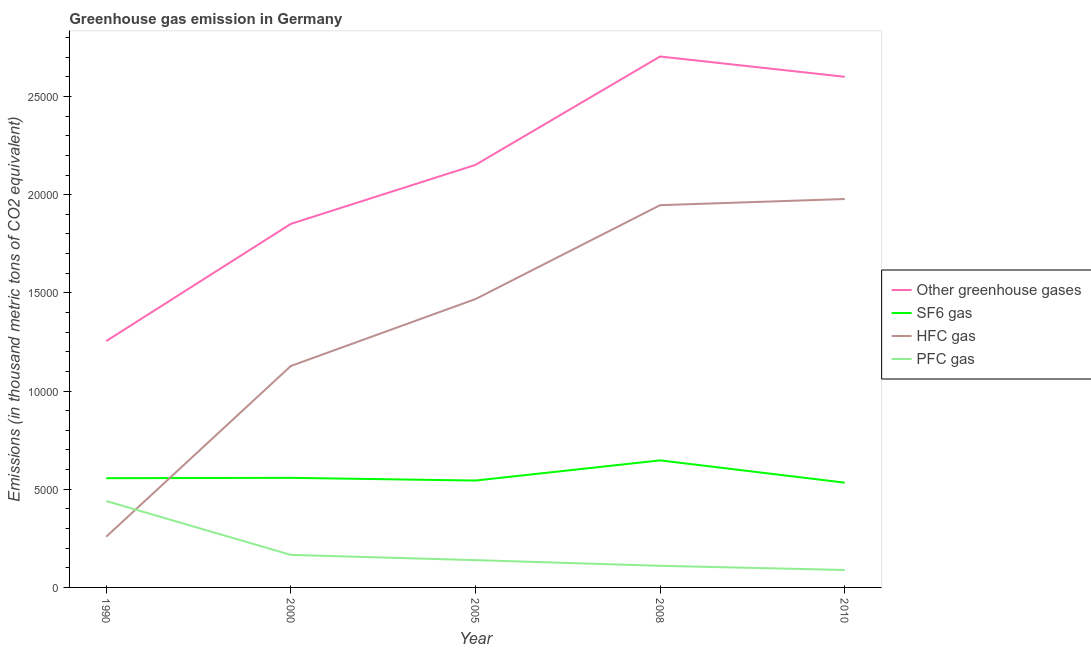Does the line corresponding to emission of hfc gas intersect with the line corresponding to emission of greenhouse gases?
Keep it short and to the point. No. What is the emission of hfc gas in 2005?
Your answer should be very brief. 1.47e+04. Across all years, what is the maximum emission of sf6 gas?
Keep it short and to the point. 6469.6. Across all years, what is the minimum emission of hfc gas?
Give a very brief answer. 2581.5. In which year was the emission of sf6 gas minimum?
Your response must be concise. 2010. What is the total emission of sf6 gas in the graph?
Provide a short and direct response. 2.84e+04. What is the difference between the emission of pfc gas in 2000 and that in 2005?
Your response must be concise. 266.2. What is the difference between the emission of sf6 gas in 2005 and the emission of hfc gas in 2008?
Provide a short and direct response. -1.40e+04. What is the average emission of greenhouse gases per year?
Offer a very short reply. 2.11e+04. In the year 2008, what is the difference between the emission of greenhouse gases and emission of hfc gas?
Your response must be concise. 7571. In how many years, is the emission of hfc gas greater than 17000 thousand metric tons?
Give a very brief answer. 2. What is the ratio of the emission of hfc gas in 2005 to that in 2008?
Provide a succinct answer. 0.75. Is the emission of sf6 gas in 1990 less than that in 2010?
Provide a short and direct response. No. What is the difference between the highest and the second highest emission of greenhouse gases?
Provide a succinct answer. 1033.8. What is the difference between the highest and the lowest emission of greenhouse gases?
Offer a very short reply. 1.45e+04. Is it the case that in every year, the sum of the emission of greenhouse gases and emission of pfc gas is greater than the sum of emission of hfc gas and emission of sf6 gas?
Offer a terse response. Yes. Is it the case that in every year, the sum of the emission of greenhouse gases and emission of sf6 gas is greater than the emission of hfc gas?
Offer a terse response. Yes. Is the emission of greenhouse gases strictly less than the emission of hfc gas over the years?
Provide a succinct answer. No. How many lines are there?
Provide a short and direct response. 4. How many years are there in the graph?
Offer a terse response. 5. What is the difference between two consecutive major ticks on the Y-axis?
Make the answer very short. 5000. Does the graph contain any zero values?
Give a very brief answer. No. Does the graph contain grids?
Your answer should be compact. No. Where does the legend appear in the graph?
Ensure brevity in your answer.  Center right. What is the title of the graph?
Ensure brevity in your answer.  Greenhouse gas emission in Germany. What is the label or title of the X-axis?
Ensure brevity in your answer.  Year. What is the label or title of the Y-axis?
Provide a succinct answer. Emissions (in thousand metric tons of CO2 equivalent). What is the Emissions (in thousand metric tons of CO2 equivalent) in Other greenhouse gases in 1990?
Provide a succinct answer. 1.25e+04. What is the Emissions (in thousand metric tons of CO2 equivalent) in SF6 gas in 1990?
Make the answer very short. 5562.9. What is the Emissions (in thousand metric tons of CO2 equivalent) in HFC gas in 1990?
Provide a short and direct response. 2581.5. What is the Emissions (in thousand metric tons of CO2 equivalent) of PFC gas in 1990?
Offer a terse response. 4401.3. What is the Emissions (in thousand metric tons of CO2 equivalent) in Other greenhouse gases in 2000?
Give a very brief answer. 1.85e+04. What is the Emissions (in thousand metric tons of CO2 equivalent) of SF6 gas in 2000?
Ensure brevity in your answer.  5580.4. What is the Emissions (in thousand metric tons of CO2 equivalent) in HFC gas in 2000?
Your answer should be compact. 1.13e+04. What is the Emissions (in thousand metric tons of CO2 equivalent) of PFC gas in 2000?
Your answer should be compact. 1655.9. What is the Emissions (in thousand metric tons of CO2 equivalent) in Other greenhouse gases in 2005?
Your answer should be compact. 2.15e+04. What is the Emissions (in thousand metric tons of CO2 equivalent) of SF6 gas in 2005?
Your response must be concise. 5443.2. What is the Emissions (in thousand metric tons of CO2 equivalent) in HFC gas in 2005?
Offer a terse response. 1.47e+04. What is the Emissions (in thousand metric tons of CO2 equivalent) of PFC gas in 2005?
Offer a terse response. 1389.7. What is the Emissions (in thousand metric tons of CO2 equivalent) in Other greenhouse gases in 2008?
Offer a terse response. 2.70e+04. What is the Emissions (in thousand metric tons of CO2 equivalent) of SF6 gas in 2008?
Ensure brevity in your answer.  6469.6. What is the Emissions (in thousand metric tons of CO2 equivalent) of HFC gas in 2008?
Provide a short and direct response. 1.95e+04. What is the Emissions (in thousand metric tons of CO2 equivalent) in PFC gas in 2008?
Keep it short and to the point. 1101.4. What is the Emissions (in thousand metric tons of CO2 equivalent) of Other greenhouse gases in 2010?
Make the answer very short. 2.60e+04. What is the Emissions (in thousand metric tons of CO2 equivalent) of SF6 gas in 2010?
Provide a succinct answer. 5336. What is the Emissions (in thousand metric tons of CO2 equivalent) in HFC gas in 2010?
Make the answer very short. 1.98e+04. What is the Emissions (in thousand metric tons of CO2 equivalent) in PFC gas in 2010?
Your response must be concise. 888. Across all years, what is the maximum Emissions (in thousand metric tons of CO2 equivalent) of Other greenhouse gases?
Make the answer very short. 2.70e+04. Across all years, what is the maximum Emissions (in thousand metric tons of CO2 equivalent) in SF6 gas?
Give a very brief answer. 6469.6. Across all years, what is the maximum Emissions (in thousand metric tons of CO2 equivalent) in HFC gas?
Offer a very short reply. 1.98e+04. Across all years, what is the maximum Emissions (in thousand metric tons of CO2 equivalent) in PFC gas?
Provide a succinct answer. 4401.3. Across all years, what is the minimum Emissions (in thousand metric tons of CO2 equivalent) of Other greenhouse gases?
Provide a short and direct response. 1.25e+04. Across all years, what is the minimum Emissions (in thousand metric tons of CO2 equivalent) of SF6 gas?
Your response must be concise. 5336. Across all years, what is the minimum Emissions (in thousand metric tons of CO2 equivalent) in HFC gas?
Your response must be concise. 2581.5. Across all years, what is the minimum Emissions (in thousand metric tons of CO2 equivalent) of PFC gas?
Provide a short and direct response. 888. What is the total Emissions (in thousand metric tons of CO2 equivalent) in Other greenhouse gases in the graph?
Offer a very short reply. 1.06e+05. What is the total Emissions (in thousand metric tons of CO2 equivalent) in SF6 gas in the graph?
Your answer should be very brief. 2.84e+04. What is the total Emissions (in thousand metric tons of CO2 equivalent) of HFC gas in the graph?
Give a very brief answer. 6.78e+04. What is the total Emissions (in thousand metric tons of CO2 equivalent) of PFC gas in the graph?
Give a very brief answer. 9436.3. What is the difference between the Emissions (in thousand metric tons of CO2 equivalent) in Other greenhouse gases in 1990 and that in 2000?
Offer a terse response. -5968.2. What is the difference between the Emissions (in thousand metric tons of CO2 equivalent) in SF6 gas in 1990 and that in 2000?
Give a very brief answer. -17.5. What is the difference between the Emissions (in thousand metric tons of CO2 equivalent) in HFC gas in 1990 and that in 2000?
Keep it short and to the point. -8696.1. What is the difference between the Emissions (in thousand metric tons of CO2 equivalent) in PFC gas in 1990 and that in 2000?
Provide a succinct answer. 2745.4. What is the difference between the Emissions (in thousand metric tons of CO2 equivalent) of Other greenhouse gases in 1990 and that in 2005?
Your answer should be very brief. -8971.8. What is the difference between the Emissions (in thousand metric tons of CO2 equivalent) in SF6 gas in 1990 and that in 2005?
Your answer should be compact. 119.7. What is the difference between the Emissions (in thousand metric tons of CO2 equivalent) in HFC gas in 1990 and that in 2005?
Your response must be concise. -1.21e+04. What is the difference between the Emissions (in thousand metric tons of CO2 equivalent) in PFC gas in 1990 and that in 2005?
Your answer should be compact. 3011.6. What is the difference between the Emissions (in thousand metric tons of CO2 equivalent) in Other greenhouse gases in 1990 and that in 2008?
Ensure brevity in your answer.  -1.45e+04. What is the difference between the Emissions (in thousand metric tons of CO2 equivalent) of SF6 gas in 1990 and that in 2008?
Your answer should be compact. -906.7. What is the difference between the Emissions (in thousand metric tons of CO2 equivalent) in HFC gas in 1990 and that in 2008?
Provide a succinct answer. -1.69e+04. What is the difference between the Emissions (in thousand metric tons of CO2 equivalent) in PFC gas in 1990 and that in 2008?
Provide a succinct answer. 3299.9. What is the difference between the Emissions (in thousand metric tons of CO2 equivalent) in Other greenhouse gases in 1990 and that in 2010?
Ensure brevity in your answer.  -1.35e+04. What is the difference between the Emissions (in thousand metric tons of CO2 equivalent) in SF6 gas in 1990 and that in 2010?
Make the answer very short. 226.9. What is the difference between the Emissions (in thousand metric tons of CO2 equivalent) in HFC gas in 1990 and that in 2010?
Your answer should be very brief. -1.72e+04. What is the difference between the Emissions (in thousand metric tons of CO2 equivalent) of PFC gas in 1990 and that in 2010?
Provide a short and direct response. 3513.3. What is the difference between the Emissions (in thousand metric tons of CO2 equivalent) in Other greenhouse gases in 2000 and that in 2005?
Provide a short and direct response. -3003.6. What is the difference between the Emissions (in thousand metric tons of CO2 equivalent) in SF6 gas in 2000 and that in 2005?
Offer a very short reply. 137.2. What is the difference between the Emissions (in thousand metric tons of CO2 equivalent) in HFC gas in 2000 and that in 2005?
Keep it short and to the point. -3407. What is the difference between the Emissions (in thousand metric tons of CO2 equivalent) of PFC gas in 2000 and that in 2005?
Offer a very short reply. 266.2. What is the difference between the Emissions (in thousand metric tons of CO2 equivalent) in Other greenhouse gases in 2000 and that in 2008?
Keep it short and to the point. -8523.9. What is the difference between the Emissions (in thousand metric tons of CO2 equivalent) in SF6 gas in 2000 and that in 2008?
Provide a succinct answer. -889.2. What is the difference between the Emissions (in thousand metric tons of CO2 equivalent) in HFC gas in 2000 and that in 2008?
Keep it short and to the point. -8189.2. What is the difference between the Emissions (in thousand metric tons of CO2 equivalent) in PFC gas in 2000 and that in 2008?
Make the answer very short. 554.5. What is the difference between the Emissions (in thousand metric tons of CO2 equivalent) in Other greenhouse gases in 2000 and that in 2010?
Keep it short and to the point. -7490.1. What is the difference between the Emissions (in thousand metric tons of CO2 equivalent) in SF6 gas in 2000 and that in 2010?
Your response must be concise. 244.4. What is the difference between the Emissions (in thousand metric tons of CO2 equivalent) in HFC gas in 2000 and that in 2010?
Provide a short and direct response. -8502.4. What is the difference between the Emissions (in thousand metric tons of CO2 equivalent) of PFC gas in 2000 and that in 2010?
Provide a short and direct response. 767.9. What is the difference between the Emissions (in thousand metric tons of CO2 equivalent) in Other greenhouse gases in 2005 and that in 2008?
Ensure brevity in your answer.  -5520.3. What is the difference between the Emissions (in thousand metric tons of CO2 equivalent) in SF6 gas in 2005 and that in 2008?
Your answer should be compact. -1026.4. What is the difference between the Emissions (in thousand metric tons of CO2 equivalent) of HFC gas in 2005 and that in 2008?
Offer a very short reply. -4782.2. What is the difference between the Emissions (in thousand metric tons of CO2 equivalent) in PFC gas in 2005 and that in 2008?
Provide a short and direct response. 288.3. What is the difference between the Emissions (in thousand metric tons of CO2 equivalent) in Other greenhouse gases in 2005 and that in 2010?
Ensure brevity in your answer.  -4486.5. What is the difference between the Emissions (in thousand metric tons of CO2 equivalent) of SF6 gas in 2005 and that in 2010?
Give a very brief answer. 107.2. What is the difference between the Emissions (in thousand metric tons of CO2 equivalent) of HFC gas in 2005 and that in 2010?
Keep it short and to the point. -5095.4. What is the difference between the Emissions (in thousand metric tons of CO2 equivalent) in PFC gas in 2005 and that in 2010?
Ensure brevity in your answer.  501.7. What is the difference between the Emissions (in thousand metric tons of CO2 equivalent) in Other greenhouse gases in 2008 and that in 2010?
Offer a terse response. 1033.8. What is the difference between the Emissions (in thousand metric tons of CO2 equivalent) in SF6 gas in 2008 and that in 2010?
Offer a very short reply. 1133.6. What is the difference between the Emissions (in thousand metric tons of CO2 equivalent) in HFC gas in 2008 and that in 2010?
Provide a short and direct response. -313.2. What is the difference between the Emissions (in thousand metric tons of CO2 equivalent) in PFC gas in 2008 and that in 2010?
Provide a succinct answer. 213.4. What is the difference between the Emissions (in thousand metric tons of CO2 equivalent) in Other greenhouse gases in 1990 and the Emissions (in thousand metric tons of CO2 equivalent) in SF6 gas in 2000?
Your answer should be compact. 6965.3. What is the difference between the Emissions (in thousand metric tons of CO2 equivalent) in Other greenhouse gases in 1990 and the Emissions (in thousand metric tons of CO2 equivalent) in HFC gas in 2000?
Offer a very short reply. 1268.1. What is the difference between the Emissions (in thousand metric tons of CO2 equivalent) in Other greenhouse gases in 1990 and the Emissions (in thousand metric tons of CO2 equivalent) in PFC gas in 2000?
Provide a short and direct response. 1.09e+04. What is the difference between the Emissions (in thousand metric tons of CO2 equivalent) in SF6 gas in 1990 and the Emissions (in thousand metric tons of CO2 equivalent) in HFC gas in 2000?
Keep it short and to the point. -5714.7. What is the difference between the Emissions (in thousand metric tons of CO2 equivalent) in SF6 gas in 1990 and the Emissions (in thousand metric tons of CO2 equivalent) in PFC gas in 2000?
Offer a very short reply. 3907. What is the difference between the Emissions (in thousand metric tons of CO2 equivalent) in HFC gas in 1990 and the Emissions (in thousand metric tons of CO2 equivalent) in PFC gas in 2000?
Offer a terse response. 925.6. What is the difference between the Emissions (in thousand metric tons of CO2 equivalent) in Other greenhouse gases in 1990 and the Emissions (in thousand metric tons of CO2 equivalent) in SF6 gas in 2005?
Offer a very short reply. 7102.5. What is the difference between the Emissions (in thousand metric tons of CO2 equivalent) of Other greenhouse gases in 1990 and the Emissions (in thousand metric tons of CO2 equivalent) of HFC gas in 2005?
Ensure brevity in your answer.  -2138.9. What is the difference between the Emissions (in thousand metric tons of CO2 equivalent) of Other greenhouse gases in 1990 and the Emissions (in thousand metric tons of CO2 equivalent) of PFC gas in 2005?
Offer a terse response. 1.12e+04. What is the difference between the Emissions (in thousand metric tons of CO2 equivalent) in SF6 gas in 1990 and the Emissions (in thousand metric tons of CO2 equivalent) in HFC gas in 2005?
Provide a short and direct response. -9121.7. What is the difference between the Emissions (in thousand metric tons of CO2 equivalent) of SF6 gas in 1990 and the Emissions (in thousand metric tons of CO2 equivalent) of PFC gas in 2005?
Make the answer very short. 4173.2. What is the difference between the Emissions (in thousand metric tons of CO2 equivalent) in HFC gas in 1990 and the Emissions (in thousand metric tons of CO2 equivalent) in PFC gas in 2005?
Give a very brief answer. 1191.8. What is the difference between the Emissions (in thousand metric tons of CO2 equivalent) in Other greenhouse gases in 1990 and the Emissions (in thousand metric tons of CO2 equivalent) in SF6 gas in 2008?
Your response must be concise. 6076.1. What is the difference between the Emissions (in thousand metric tons of CO2 equivalent) of Other greenhouse gases in 1990 and the Emissions (in thousand metric tons of CO2 equivalent) of HFC gas in 2008?
Your answer should be very brief. -6921.1. What is the difference between the Emissions (in thousand metric tons of CO2 equivalent) in Other greenhouse gases in 1990 and the Emissions (in thousand metric tons of CO2 equivalent) in PFC gas in 2008?
Offer a very short reply. 1.14e+04. What is the difference between the Emissions (in thousand metric tons of CO2 equivalent) of SF6 gas in 1990 and the Emissions (in thousand metric tons of CO2 equivalent) of HFC gas in 2008?
Provide a short and direct response. -1.39e+04. What is the difference between the Emissions (in thousand metric tons of CO2 equivalent) of SF6 gas in 1990 and the Emissions (in thousand metric tons of CO2 equivalent) of PFC gas in 2008?
Your response must be concise. 4461.5. What is the difference between the Emissions (in thousand metric tons of CO2 equivalent) of HFC gas in 1990 and the Emissions (in thousand metric tons of CO2 equivalent) of PFC gas in 2008?
Ensure brevity in your answer.  1480.1. What is the difference between the Emissions (in thousand metric tons of CO2 equivalent) of Other greenhouse gases in 1990 and the Emissions (in thousand metric tons of CO2 equivalent) of SF6 gas in 2010?
Make the answer very short. 7209.7. What is the difference between the Emissions (in thousand metric tons of CO2 equivalent) in Other greenhouse gases in 1990 and the Emissions (in thousand metric tons of CO2 equivalent) in HFC gas in 2010?
Keep it short and to the point. -7234.3. What is the difference between the Emissions (in thousand metric tons of CO2 equivalent) in Other greenhouse gases in 1990 and the Emissions (in thousand metric tons of CO2 equivalent) in PFC gas in 2010?
Your answer should be compact. 1.17e+04. What is the difference between the Emissions (in thousand metric tons of CO2 equivalent) of SF6 gas in 1990 and the Emissions (in thousand metric tons of CO2 equivalent) of HFC gas in 2010?
Make the answer very short. -1.42e+04. What is the difference between the Emissions (in thousand metric tons of CO2 equivalent) in SF6 gas in 1990 and the Emissions (in thousand metric tons of CO2 equivalent) in PFC gas in 2010?
Keep it short and to the point. 4674.9. What is the difference between the Emissions (in thousand metric tons of CO2 equivalent) of HFC gas in 1990 and the Emissions (in thousand metric tons of CO2 equivalent) of PFC gas in 2010?
Your answer should be compact. 1693.5. What is the difference between the Emissions (in thousand metric tons of CO2 equivalent) of Other greenhouse gases in 2000 and the Emissions (in thousand metric tons of CO2 equivalent) of SF6 gas in 2005?
Provide a succinct answer. 1.31e+04. What is the difference between the Emissions (in thousand metric tons of CO2 equivalent) in Other greenhouse gases in 2000 and the Emissions (in thousand metric tons of CO2 equivalent) in HFC gas in 2005?
Make the answer very short. 3829.3. What is the difference between the Emissions (in thousand metric tons of CO2 equivalent) of Other greenhouse gases in 2000 and the Emissions (in thousand metric tons of CO2 equivalent) of PFC gas in 2005?
Your response must be concise. 1.71e+04. What is the difference between the Emissions (in thousand metric tons of CO2 equivalent) of SF6 gas in 2000 and the Emissions (in thousand metric tons of CO2 equivalent) of HFC gas in 2005?
Give a very brief answer. -9104.2. What is the difference between the Emissions (in thousand metric tons of CO2 equivalent) in SF6 gas in 2000 and the Emissions (in thousand metric tons of CO2 equivalent) in PFC gas in 2005?
Your answer should be compact. 4190.7. What is the difference between the Emissions (in thousand metric tons of CO2 equivalent) in HFC gas in 2000 and the Emissions (in thousand metric tons of CO2 equivalent) in PFC gas in 2005?
Your response must be concise. 9887.9. What is the difference between the Emissions (in thousand metric tons of CO2 equivalent) of Other greenhouse gases in 2000 and the Emissions (in thousand metric tons of CO2 equivalent) of SF6 gas in 2008?
Your response must be concise. 1.20e+04. What is the difference between the Emissions (in thousand metric tons of CO2 equivalent) of Other greenhouse gases in 2000 and the Emissions (in thousand metric tons of CO2 equivalent) of HFC gas in 2008?
Provide a short and direct response. -952.9. What is the difference between the Emissions (in thousand metric tons of CO2 equivalent) in Other greenhouse gases in 2000 and the Emissions (in thousand metric tons of CO2 equivalent) in PFC gas in 2008?
Offer a terse response. 1.74e+04. What is the difference between the Emissions (in thousand metric tons of CO2 equivalent) of SF6 gas in 2000 and the Emissions (in thousand metric tons of CO2 equivalent) of HFC gas in 2008?
Offer a terse response. -1.39e+04. What is the difference between the Emissions (in thousand metric tons of CO2 equivalent) in SF6 gas in 2000 and the Emissions (in thousand metric tons of CO2 equivalent) in PFC gas in 2008?
Provide a short and direct response. 4479. What is the difference between the Emissions (in thousand metric tons of CO2 equivalent) in HFC gas in 2000 and the Emissions (in thousand metric tons of CO2 equivalent) in PFC gas in 2008?
Provide a succinct answer. 1.02e+04. What is the difference between the Emissions (in thousand metric tons of CO2 equivalent) in Other greenhouse gases in 2000 and the Emissions (in thousand metric tons of CO2 equivalent) in SF6 gas in 2010?
Ensure brevity in your answer.  1.32e+04. What is the difference between the Emissions (in thousand metric tons of CO2 equivalent) of Other greenhouse gases in 2000 and the Emissions (in thousand metric tons of CO2 equivalent) of HFC gas in 2010?
Give a very brief answer. -1266.1. What is the difference between the Emissions (in thousand metric tons of CO2 equivalent) of Other greenhouse gases in 2000 and the Emissions (in thousand metric tons of CO2 equivalent) of PFC gas in 2010?
Ensure brevity in your answer.  1.76e+04. What is the difference between the Emissions (in thousand metric tons of CO2 equivalent) of SF6 gas in 2000 and the Emissions (in thousand metric tons of CO2 equivalent) of HFC gas in 2010?
Your answer should be very brief. -1.42e+04. What is the difference between the Emissions (in thousand metric tons of CO2 equivalent) in SF6 gas in 2000 and the Emissions (in thousand metric tons of CO2 equivalent) in PFC gas in 2010?
Offer a very short reply. 4692.4. What is the difference between the Emissions (in thousand metric tons of CO2 equivalent) of HFC gas in 2000 and the Emissions (in thousand metric tons of CO2 equivalent) of PFC gas in 2010?
Your answer should be very brief. 1.04e+04. What is the difference between the Emissions (in thousand metric tons of CO2 equivalent) in Other greenhouse gases in 2005 and the Emissions (in thousand metric tons of CO2 equivalent) in SF6 gas in 2008?
Give a very brief answer. 1.50e+04. What is the difference between the Emissions (in thousand metric tons of CO2 equivalent) of Other greenhouse gases in 2005 and the Emissions (in thousand metric tons of CO2 equivalent) of HFC gas in 2008?
Provide a succinct answer. 2050.7. What is the difference between the Emissions (in thousand metric tons of CO2 equivalent) in Other greenhouse gases in 2005 and the Emissions (in thousand metric tons of CO2 equivalent) in PFC gas in 2008?
Give a very brief answer. 2.04e+04. What is the difference between the Emissions (in thousand metric tons of CO2 equivalent) of SF6 gas in 2005 and the Emissions (in thousand metric tons of CO2 equivalent) of HFC gas in 2008?
Ensure brevity in your answer.  -1.40e+04. What is the difference between the Emissions (in thousand metric tons of CO2 equivalent) of SF6 gas in 2005 and the Emissions (in thousand metric tons of CO2 equivalent) of PFC gas in 2008?
Provide a succinct answer. 4341.8. What is the difference between the Emissions (in thousand metric tons of CO2 equivalent) in HFC gas in 2005 and the Emissions (in thousand metric tons of CO2 equivalent) in PFC gas in 2008?
Your answer should be compact. 1.36e+04. What is the difference between the Emissions (in thousand metric tons of CO2 equivalent) in Other greenhouse gases in 2005 and the Emissions (in thousand metric tons of CO2 equivalent) in SF6 gas in 2010?
Make the answer very short. 1.62e+04. What is the difference between the Emissions (in thousand metric tons of CO2 equivalent) of Other greenhouse gases in 2005 and the Emissions (in thousand metric tons of CO2 equivalent) of HFC gas in 2010?
Offer a terse response. 1737.5. What is the difference between the Emissions (in thousand metric tons of CO2 equivalent) in Other greenhouse gases in 2005 and the Emissions (in thousand metric tons of CO2 equivalent) in PFC gas in 2010?
Your answer should be very brief. 2.06e+04. What is the difference between the Emissions (in thousand metric tons of CO2 equivalent) in SF6 gas in 2005 and the Emissions (in thousand metric tons of CO2 equivalent) in HFC gas in 2010?
Offer a terse response. -1.43e+04. What is the difference between the Emissions (in thousand metric tons of CO2 equivalent) of SF6 gas in 2005 and the Emissions (in thousand metric tons of CO2 equivalent) of PFC gas in 2010?
Keep it short and to the point. 4555.2. What is the difference between the Emissions (in thousand metric tons of CO2 equivalent) of HFC gas in 2005 and the Emissions (in thousand metric tons of CO2 equivalent) of PFC gas in 2010?
Your answer should be compact. 1.38e+04. What is the difference between the Emissions (in thousand metric tons of CO2 equivalent) of Other greenhouse gases in 2008 and the Emissions (in thousand metric tons of CO2 equivalent) of SF6 gas in 2010?
Your answer should be very brief. 2.17e+04. What is the difference between the Emissions (in thousand metric tons of CO2 equivalent) of Other greenhouse gases in 2008 and the Emissions (in thousand metric tons of CO2 equivalent) of HFC gas in 2010?
Your answer should be compact. 7257.8. What is the difference between the Emissions (in thousand metric tons of CO2 equivalent) in Other greenhouse gases in 2008 and the Emissions (in thousand metric tons of CO2 equivalent) in PFC gas in 2010?
Offer a terse response. 2.61e+04. What is the difference between the Emissions (in thousand metric tons of CO2 equivalent) in SF6 gas in 2008 and the Emissions (in thousand metric tons of CO2 equivalent) in HFC gas in 2010?
Ensure brevity in your answer.  -1.33e+04. What is the difference between the Emissions (in thousand metric tons of CO2 equivalent) in SF6 gas in 2008 and the Emissions (in thousand metric tons of CO2 equivalent) in PFC gas in 2010?
Offer a very short reply. 5581.6. What is the difference between the Emissions (in thousand metric tons of CO2 equivalent) in HFC gas in 2008 and the Emissions (in thousand metric tons of CO2 equivalent) in PFC gas in 2010?
Offer a very short reply. 1.86e+04. What is the average Emissions (in thousand metric tons of CO2 equivalent) of Other greenhouse gases per year?
Give a very brief answer. 2.11e+04. What is the average Emissions (in thousand metric tons of CO2 equivalent) in SF6 gas per year?
Keep it short and to the point. 5678.42. What is the average Emissions (in thousand metric tons of CO2 equivalent) in HFC gas per year?
Provide a short and direct response. 1.36e+04. What is the average Emissions (in thousand metric tons of CO2 equivalent) of PFC gas per year?
Offer a very short reply. 1887.26. In the year 1990, what is the difference between the Emissions (in thousand metric tons of CO2 equivalent) in Other greenhouse gases and Emissions (in thousand metric tons of CO2 equivalent) in SF6 gas?
Provide a succinct answer. 6982.8. In the year 1990, what is the difference between the Emissions (in thousand metric tons of CO2 equivalent) in Other greenhouse gases and Emissions (in thousand metric tons of CO2 equivalent) in HFC gas?
Give a very brief answer. 9964.2. In the year 1990, what is the difference between the Emissions (in thousand metric tons of CO2 equivalent) of Other greenhouse gases and Emissions (in thousand metric tons of CO2 equivalent) of PFC gas?
Your response must be concise. 8144.4. In the year 1990, what is the difference between the Emissions (in thousand metric tons of CO2 equivalent) in SF6 gas and Emissions (in thousand metric tons of CO2 equivalent) in HFC gas?
Keep it short and to the point. 2981.4. In the year 1990, what is the difference between the Emissions (in thousand metric tons of CO2 equivalent) of SF6 gas and Emissions (in thousand metric tons of CO2 equivalent) of PFC gas?
Ensure brevity in your answer.  1161.6. In the year 1990, what is the difference between the Emissions (in thousand metric tons of CO2 equivalent) of HFC gas and Emissions (in thousand metric tons of CO2 equivalent) of PFC gas?
Provide a succinct answer. -1819.8. In the year 2000, what is the difference between the Emissions (in thousand metric tons of CO2 equivalent) of Other greenhouse gases and Emissions (in thousand metric tons of CO2 equivalent) of SF6 gas?
Your answer should be very brief. 1.29e+04. In the year 2000, what is the difference between the Emissions (in thousand metric tons of CO2 equivalent) of Other greenhouse gases and Emissions (in thousand metric tons of CO2 equivalent) of HFC gas?
Ensure brevity in your answer.  7236.3. In the year 2000, what is the difference between the Emissions (in thousand metric tons of CO2 equivalent) of Other greenhouse gases and Emissions (in thousand metric tons of CO2 equivalent) of PFC gas?
Provide a succinct answer. 1.69e+04. In the year 2000, what is the difference between the Emissions (in thousand metric tons of CO2 equivalent) of SF6 gas and Emissions (in thousand metric tons of CO2 equivalent) of HFC gas?
Give a very brief answer. -5697.2. In the year 2000, what is the difference between the Emissions (in thousand metric tons of CO2 equivalent) of SF6 gas and Emissions (in thousand metric tons of CO2 equivalent) of PFC gas?
Your response must be concise. 3924.5. In the year 2000, what is the difference between the Emissions (in thousand metric tons of CO2 equivalent) of HFC gas and Emissions (in thousand metric tons of CO2 equivalent) of PFC gas?
Offer a terse response. 9621.7. In the year 2005, what is the difference between the Emissions (in thousand metric tons of CO2 equivalent) of Other greenhouse gases and Emissions (in thousand metric tons of CO2 equivalent) of SF6 gas?
Your answer should be very brief. 1.61e+04. In the year 2005, what is the difference between the Emissions (in thousand metric tons of CO2 equivalent) of Other greenhouse gases and Emissions (in thousand metric tons of CO2 equivalent) of HFC gas?
Give a very brief answer. 6832.9. In the year 2005, what is the difference between the Emissions (in thousand metric tons of CO2 equivalent) in Other greenhouse gases and Emissions (in thousand metric tons of CO2 equivalent) in PFC gas?
Your answer should be compact. 2.01e+04. In the year 2005, what is the difference between the Emissions (in thousand metric tons of CO2 equivalent) of SF6 gas and Emissions (in thousand metric tons of CO2 equivalent) of HFC gas?
Give a very brief answer. -9241.4. In the year 2005, what is the difference between the Emissions (in thousand metric tons of CO2 equivalent) in SF6 gas and Emissions (in thousand metric tons of CO2 equivalent) in PFC gas?
Keep it short and to the point. 4053.5. In the year 2005, what is the difference between the Emissions (in thousand metric tons of CO2 equivalent) in HFC gas and Emissions (in thousand metric tons of CO2 equivalent) in PFC gas?
Offer a very short reply. 1.33e+04. In the year 2008, what is the difference between the Emissions (in thousand metric tons of CO2 equivalent) in Other greenhouse gases and Emissions (in thousand metric tons of CO2 equivalent) in SF6 gas?
Keep it short and to the point. 2.06e+04. In the year 2008, what is the difference between the Emissions (in thousand metric tons of CO2 equivalent) of Other greenhouse gases and Emissions (in thousand metric tons of CO2 equivalent) of HFC gas?
Keep it short and to the point. 7571. In the year 2008, what is the difference between the Emissions (in thousand metric tons of CO2 equivalent) of Other greenhouse gases and Emissions (in thousand metric tons of CO2 equivalent) of PFC gas?
Ensure brevity in your answer.  2.59e+04. In the year 2008, what is the difference between the Emissions (in thousand metric tons of CO2 equivalent) in SF6 gas and Emissions (in thousand metric tons of CO2 equivalent) in HFC gas?
Make the answer very short. -1.30e+04. In the year 2008, what is the difference between the Emissions (in thousand metric tons of CO2 equivalent) in SF6 gas and Emissions (in thousand metric tons of CO2 equivalent) in PFC gas?
Provide a succinct answer. 5368.2. In the year 2008, what is the difference between the Emissions (in thousand metric tons of CO2 equivalent) in HFC gas and Emissions (in thousand metric tons of CO2 equivalent) in PFC gas?
Offer a terse response. 1.84e+04. In the year 2010, what is the difference between the Emissions (in thousand metric tons of CO2 equivalent) of Other greenhouse gases and Emissions (in thousand metric tons of CO2 equivalent) of SF6 gas?
Provide a succinct answer. 2.07e+04. In the year 2010, what is the difference between the Emissions (in thousand metric tons of CO2 equivalent) of Other greenhouse gases and Emissions (in thousand metric tons of CO2 equivalent) of HFC gas?
Offer a very short reply. 6224. In the year 2010, what is the difference between the Emissions (in thousand metric tons of CO2 equivalent) of Other greenhouse gases and Emissions (in thousand metric tons of CO2 equivalent) of PFC gas?
Ensure brevity in your answer.  2.51e+04. In the year 2010, what is the difference between the Emissions (in thousand metric tons of CO2 equivalent) of SF6 gas and Emissions (in thousand metric tons of CO2 equivalent) of HFC gas?
Offer a terse response. -1.44e+04. In the year 2010, what is the difference between the Emissions (in thousand metric tons of CO2 equivalent) in SF6 gas and Emissions (in thousand metric tons of CO2 equivalent) in PFC gas?
Your answer should be compact. 4448. In the year 2010, what is the difference between the Emissions (in thousand metric tons of CO2 equivalent) of HFC gas and Emissions (in thousand metric tons of CO2 equivalent) of PFC gas?
Provide a short and direct response. 1.89e+04. What is the ratio of the Emissions (in thousand metric tons of CO2 equivalent) in Other greenhouse gases in 1990 to that in 2000?
Your answer should be compact. 0.68. What is the ratio of the Emissions (in thousand metric tons of CO2 equivalent) of SF6 gas in 1990 to that in 2000?
Offer a very short reply. 1. What is the ratio of the Emissions (in thousand metric tons of CO2 equivalent) of HFC gas in 1990 to that in 2000?
Your answer should be compact. 0.23. What is the ratio of the Emissions (in thousand metric tons of CO2 equivalent) of PFC gas in 1990 to that in 2000?
Provide a short and direct response. 2.66. What is the ratio of the Emissions (in thousand metric tons of CO2 equivalent) in Other greenhouse gases in 1990 to that in 2005?
Your answer should be compact. 0.58. What is the ratio of the Emissions (in thousand metric tons of CO2 equivalent) of SF6 gas in 1990 to that in 2005?
Your answer should be very brief. 1.02. What is the ratio of the Emissions (in thousand metric tons of CO2 equivalent) of HFC gas in 1990 to that in 2005?
Offer a terse response. 0.18. What is the ratio of the Emissions (in thousand metric tons of CO2 equivalent) of PFC gas in 1990 to that in 2005?
Keep it short and to the point. 3.17. What is the ratio of the Emissions (in thousand metric tons of CO2 equivalent) of Other greenhouse gases in 1990 to that in 2008?
Your response must be concise. 0.46. What is the ratio of the Emissions (in thousand metric tons of CO2 equivalent) in SF6 gas in 1990 to that in 2008?
Make the answer very short. 0.86. What is the ratio of the Emissions (in thousand metric tons of CO2 equivalent) in HFC gas in 1990 to that in 2008?
Keep it short and to the point. 0.13. What is the ratio of the Emissions (in thousand metric tons of CO2 equivalent) of PFC gas in 1990 to that in 2008?
Ensure brevity in your answer.  4. What is the ratio of the Emissions (in thousand metric tons of CO2 equivalent) in Other greenhouse gases in 1990 to that in 2010?
Offer a terse response. 0.48. What is the ratio of the Emissions (in thousand metric tons of CO2 equivalent) in SF6 gas in 1990 to that in 2010?
Keep it short and to the point. 1.04. What is the ratio of the Emissions (in thousand metric tons of CO2 equivalent) in HFC gas in 1990 to that in 2010?
Provide a succinct answer. 0.13. What is the ratio of the Emissions (in thousand metric tons of CO2 equivalent) of PFC gas in 1990 to that in 2010?
Provide a short and direct response. 4.96. What is the ratio of the Emissions (in thousand metric tons of CO2 equivalent) in Other greenhouse gases in 2000 to that in 2005?
Give a very brief answer. 0.86. What is the ratio of the Emissions (in thousand metric tons of CO2 equivalent) in SF6 gas in 2000 to that in 2005?
Give a very brief answer. 1.03. What is the ratio of the Emissions (in thousand metric tons of CO2 equivalent) in HFC gas in 2000 to that in 2005?
Your response must be concise. 0.77. What is the ratio of the Emissions (in thousand metric tons of CO2 equivalent) of PFC gas in 2000 to that in 2005?
Your answer should be very brief. 1.19. What is the ratio of the Emissions (in thousand metric tons of CO2 equivalent) of Other greenhouse gases in 2000 to that in 2008?
Ensure brevity in your answer.  0.68. What is the ratio of the Emissions (in thousand metric tons of CO2 equivalent) of SF6 gas in 2000 to that in 2008?
Make the answer very short. 0.86. What is the ratio of the Emissions (in thousand metric tons of CO2 equivalent) of HFC gas in 2000 to that in 2008?
Ensure brevity in your answer.  0.58. What is the ratio of the Emissions (in thousand metric tons of CO2 equivalent) in PFC gas in 2000 to that in 2008?
Ensure brevity in your answer.  1.5. What is the ratio of the Emissions (in thousand metric tons of CO2 equivalent) of Other greenhouse gases in 2000 to that in 2010?
Your response must be concise. 0.71. What is the ratio of the Emissions (in thousand metric tons of CO2 equivalent) in SF6 gas in 2000 to that in 2010?
Ensure brevity in your answer.  1.05. What is the ratio of the Emissions (in thousand metric tons of CO2 equivalent) of HFC gas in 2000 to that in 2010?
Offer a terse response. 0.57. What is the ratio of the Emissions (in thousand metric tons of CO2 equivalent) of PFC gas in 2000 to that in 2010?
Offer a terse response. 1.86. What is the ratio of the Emissions (in thousand metric tons of CO2 equivalent) in Other greenhouse gases in 2005 to that in 2008?
Make the answer very short. 0.8. What is the ratio of the Emissions (in thousand metric tons of CO2 equivalent) in SF6 gas in 2005 to that in 2008?
Provide a short and direct response. 0.84. What is the ratio of the Emissions (in thousand metric tons of CO2 equivalent) of HFC gas in 2005 to that in 2008?
Make the answer very short. 0.75. What is the ratio of the Emissions (in thousand metric tons of CO2 equivalent) of PFC gas in 2005 to that in 2008?
Ensure brevity in your answer.  1.26. What is the ratio of the Emissions (in thousand metric tons of CO2 equivalent) of Other greenhouse gases in 2005 to that in 2010?
Offer a very short reply. 0.83. What is the ratio of the Emissions (in thousand metric tons of CO2 equivalent) of SF6 gas in 2005 to that in 2010?
Offer a terse response. 1.02. What is the ratio of the Emissions (in thousand metric tons of CO2 equivalent) of HFC gas in 2005 to that in 2010?
Make the answer very short. 0.74. What is the ratio of the Emissions (in thousand metric tons of CO2 equivalent) in PFC gas in 2005 to that in 2010?
Ensure brevity in your answer.  1.56. What is the ratio of the Emissions (in thousand metric tons of CO2 equivalent) in Other greenhouse gases in 2008 to that in 2010?
Provide a succinct answer. 1.04. What is the ratio of the Emissions (in thousand metric tons of CO2 equivalent) of SF6 gas in 2008 to that in 2010?
Ensure brevity in your answer.  1.21. What is the ratio of the Emissions (in thousand metric tons of CO2 equivalent) in HFC gas in 2008 to that in 2010?
Ensure brevity in your answer.  0.98. What is the ratio of the Emissions (in thousand metric tons of CO2 equivalent) in PFC gas in 2008 to that in 2010?
Offer a terse response. 1.24. What is the difference between the highest and the second highest Emissions (in thousand metric tons of CO2 equivalent) in Other greenhouse gases?
Offer a terse response. 1033.8. What is the difference between the highest and the second highest Emissions (in thousand metric tons of CO2 equivalent) in SF6 gas?
Make the answer very short. 889.2. What is the difference between the highest and the second highest Emissions (in thousand metric tons of CO2 equivalent) of HFC gas?
Ensure brevity in your answer.  313.2. What is the difference between the highest and the second highest Emissions (in thousand metric tons of CO2 equivalent) in PFC gas?
Give a very brief answer. 2745.4. What is the difference between the highest and the lowest Emissions (in thousand metric tons of CO2 equivalent) of Other greenhouse gases?
Your response must be concise. 1.45e+04. What is the difference between the highest and the lowest Emissions (in thousand metric tons of CO2 equivalent) of SF6 gas?
Give a very brief answer. 1133.6. What is the difference between the highest and the lowest Emissions (in thousand metric tons of CO2 equivalent) of HFC gas?
Your answer should be very brief. 1.72e+04. What is the difference between the highest and the lowest Emissions (in thousand metric tons of CO2 equivalent) in PFC gas?
Keep it short and to the point. 3513.3. 